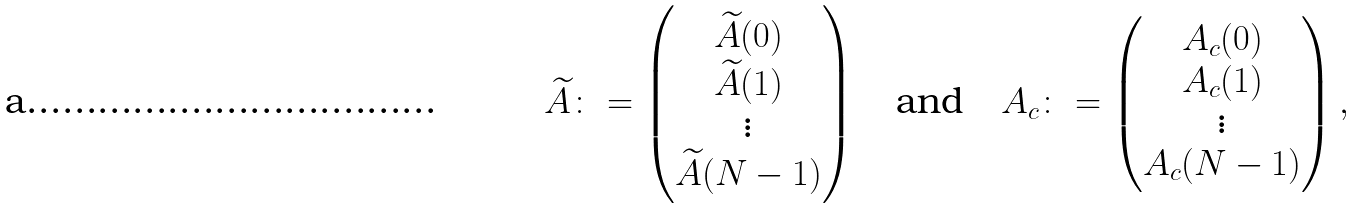<formula> <loc_0><loc_0><loc_500><loc_500>\widetilde { A } \colon = \begin{pmatrix} \widetilde { A } ( 0 ) \\ \widetilde { A } ( 1 ) \\ \vdots \\ \widetilde { A } ( N - 1 ) \end{pmatrix} \quad \text {and} \quad A _ { c } \colon = \begin{pmatrix} A _ { c } ( 0 ) \\ A _ { c } ( 1 ) \\ \vdots \\ A _ { c } ( N - 1 ) \end{pmatrix} ,</formula> 